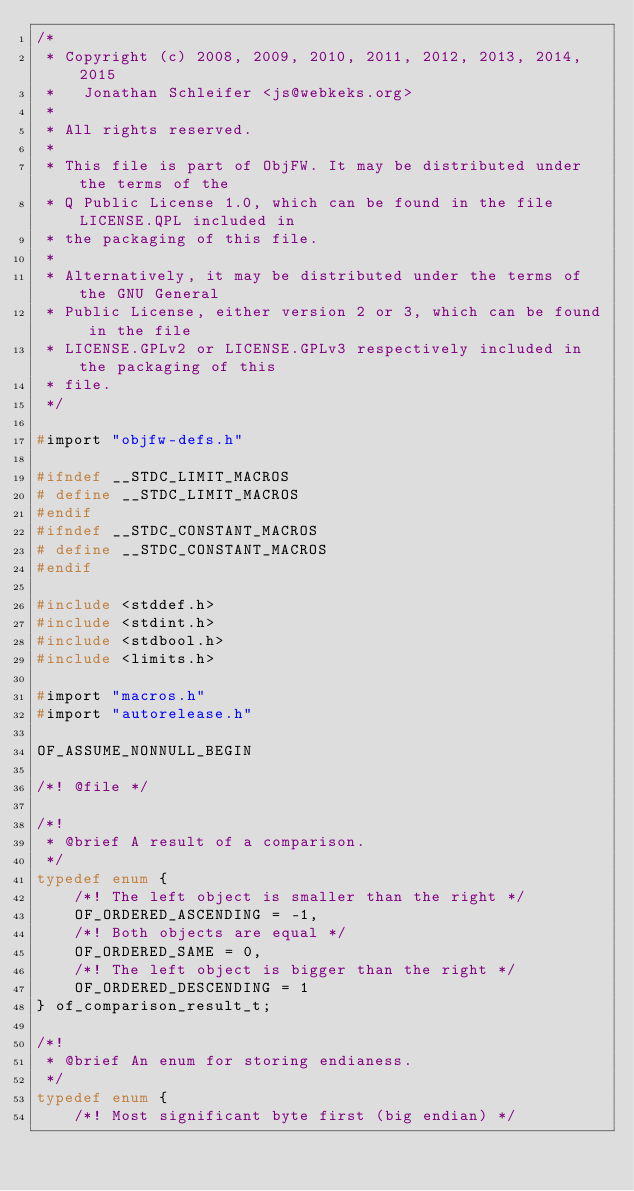<code> <loc_0><loc_0><loc_500><loc_500><_C_>/*
 * Copyright (c) 2008, 2009, 2010, 2011, 2012, 2013, 2014, 2015
 *   Jonathan Schleifer <js@webkeks.org>
 *
 * All rights reserved.
 *
 * This file is part of ObjFW. It may be distributed under the terms of the
 * Q Public License 1.0, which can be found in the file LICENSE.QPL included in
 * the packaging of this file.
 *
 * Alternatively, it may be distributed under the terms of the GNU General
 * Public License, either version 2 or 3, which can be found in the file
 * LICENSE.GPLv2 or LICENSE.GPLv3 respectively included in the packaging of this
 * file.
 */

#import "objfw-defs.h"

#ifndef __STDC_LIMIT_MACROS
# define __STDC_LIMIT_MACROS
#endif
#ifndef __STDC_CONSTANT_MACROS
# define __STDC_CONSTANT_MACROS
#endif

#include <stddef.h>
#include <stdint.h>
#include <stdbool.h>
#include <limits.h>

#import "macros.h"
#import "autorelease.h"

OF_ASSUME_NONNULL_BEGIN

/*! @file */

/*!
 * @brief A result of a comparison.
 */
typedef enum {
	/*! The left object is smaller than the right */
	OF_ORDERED_ASCENDING = -1,
	/*! Both objects are equal */
	OF_ORDERED_SAME = 0,
	/*! The left object is bigger than the right */
	OF_ORDERED_DESCENDING = 1
} of_comparison_result_t;

/*!
 * @brief An enum for storing endianess.
 */
typedef enum {
	/*! Most significant byte first (big endian) */</code> 